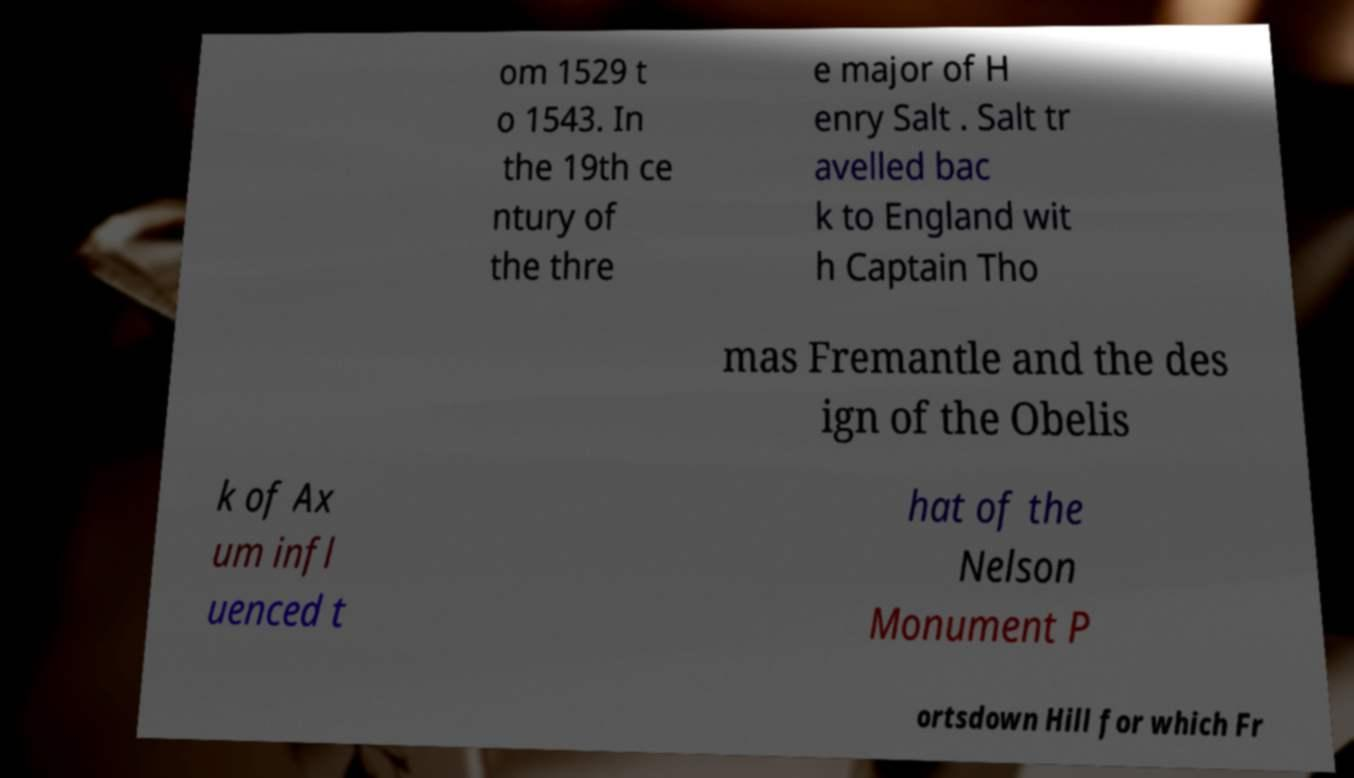Could you assist in decoding the text presented in this image and type it out clearly? om 1529 t o 1543. In the 19th ce ntury of the thre e major of H enry Salt . Salt tr avelled bac k to England wit h Captain Tho mas Fremantle and the des ign of the Obelis k of Ax um infl uenced t hat of the Nelson Monument P ortsdown Hill for which Fr 